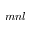Convert formula to latex. <formula><loc_0><loc_0><loc_500><loc_500>m n l</formula> 